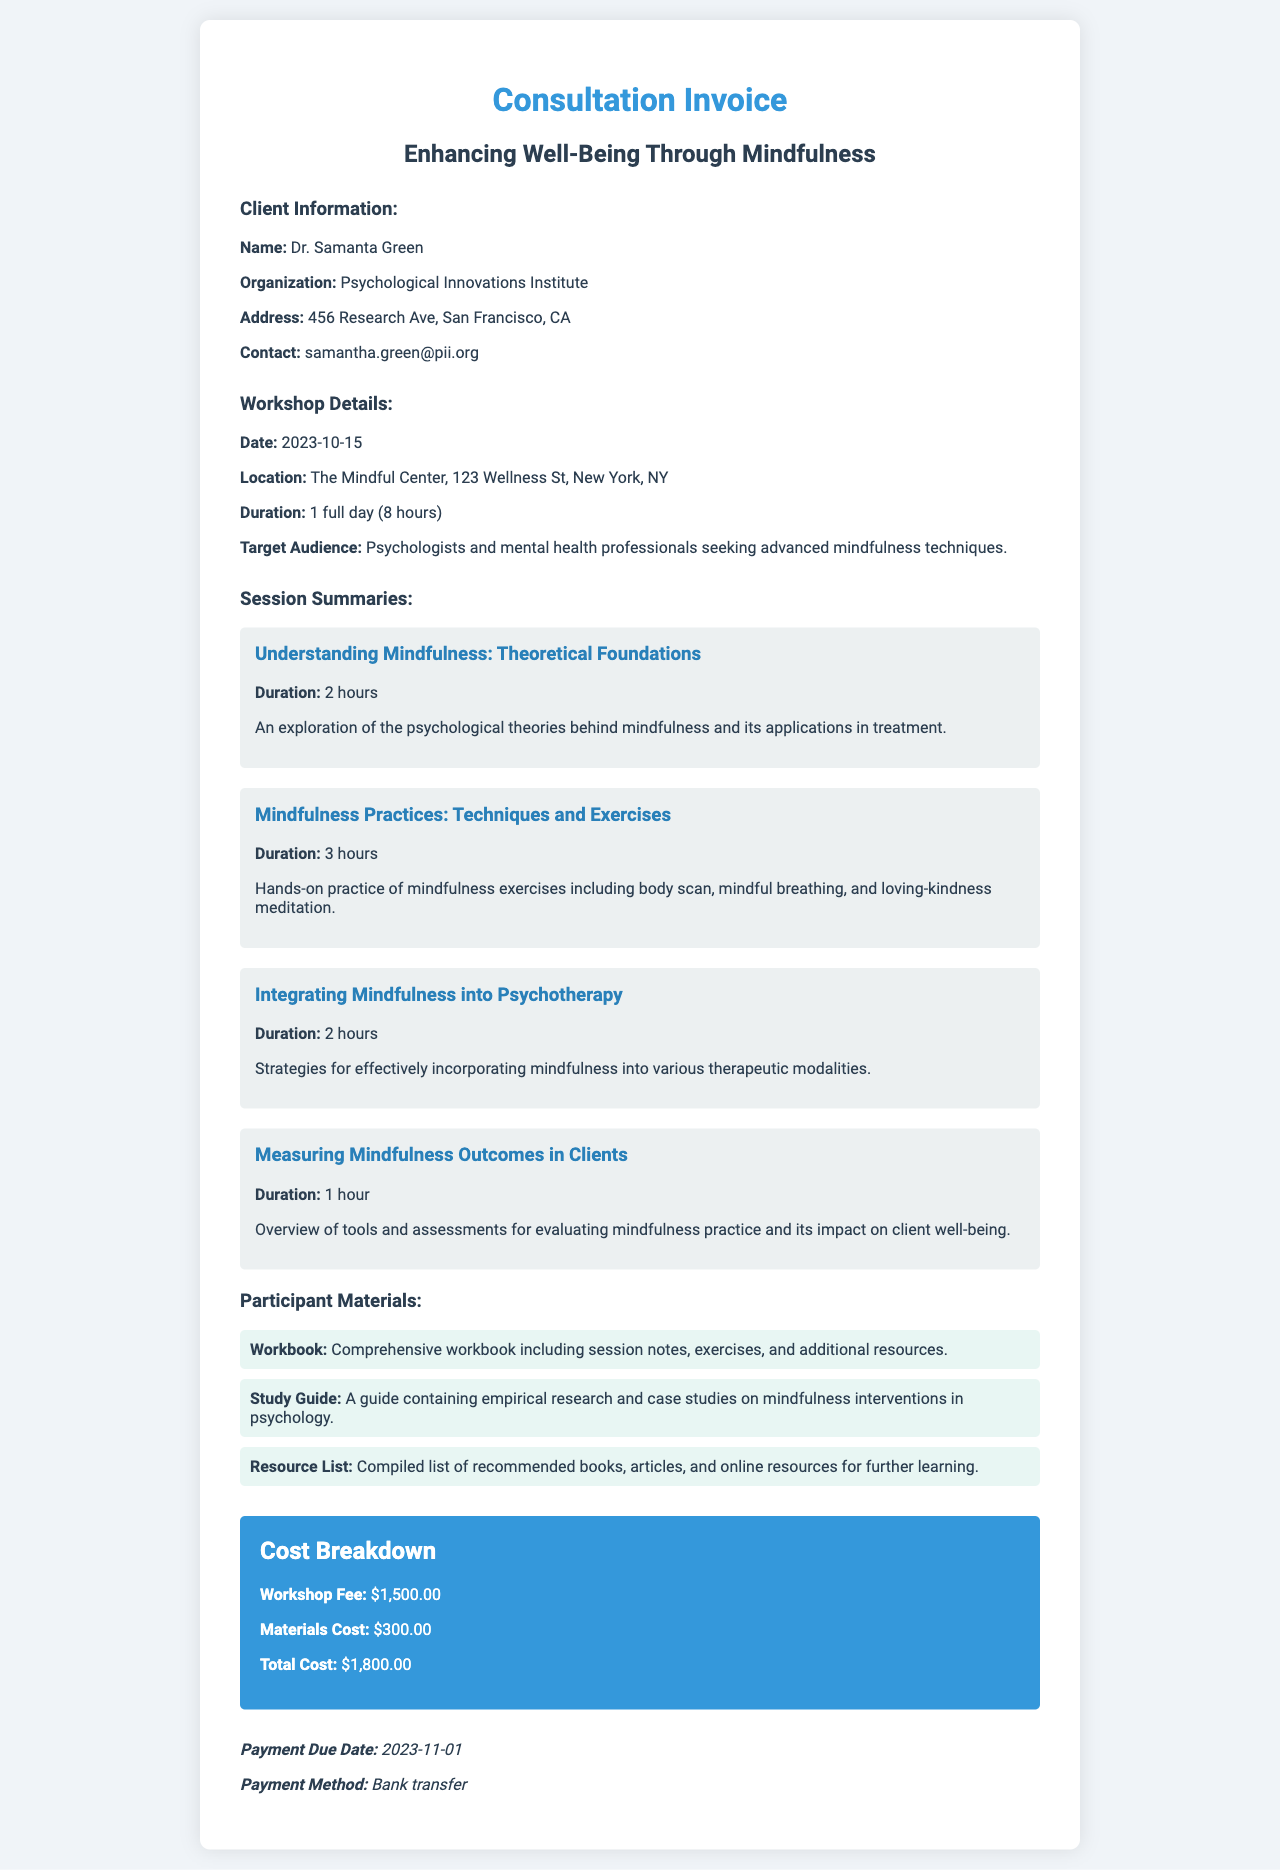What is the client's name? The client's name is listed in the document under Client Information.
Answer: Dr. Samanta Green What is the location of the workshop? The location is indicated in the Workshop Details section of the document.
Answer: The Mindful Center, 123 Wellness St, New York, NY How long is the workshop? The duration of the workshop is provided in the workshop details.
Answer: 1 full day (8 hours) What are the participant materials listed? The participant materials are detailed in their own section of the document.
Answer: Workbook, Study Guide, Resource List What is the total cost of the workshop? The total cost is calculated in the Cost Breakdown section of the invoice.
Answer: $1,800.00 How many hours are dedicated to the "Understanding Mindfulness" session? This information can be found in the Session Summaries section.
Answer: 2 hours What payment method is specified? This is mentioned in the Payment Terms section of the invoice.
Answer: Bank transfer What is the due date for payment? The payment due date is provided at the end of the document.
Answer: 2023-11-01 